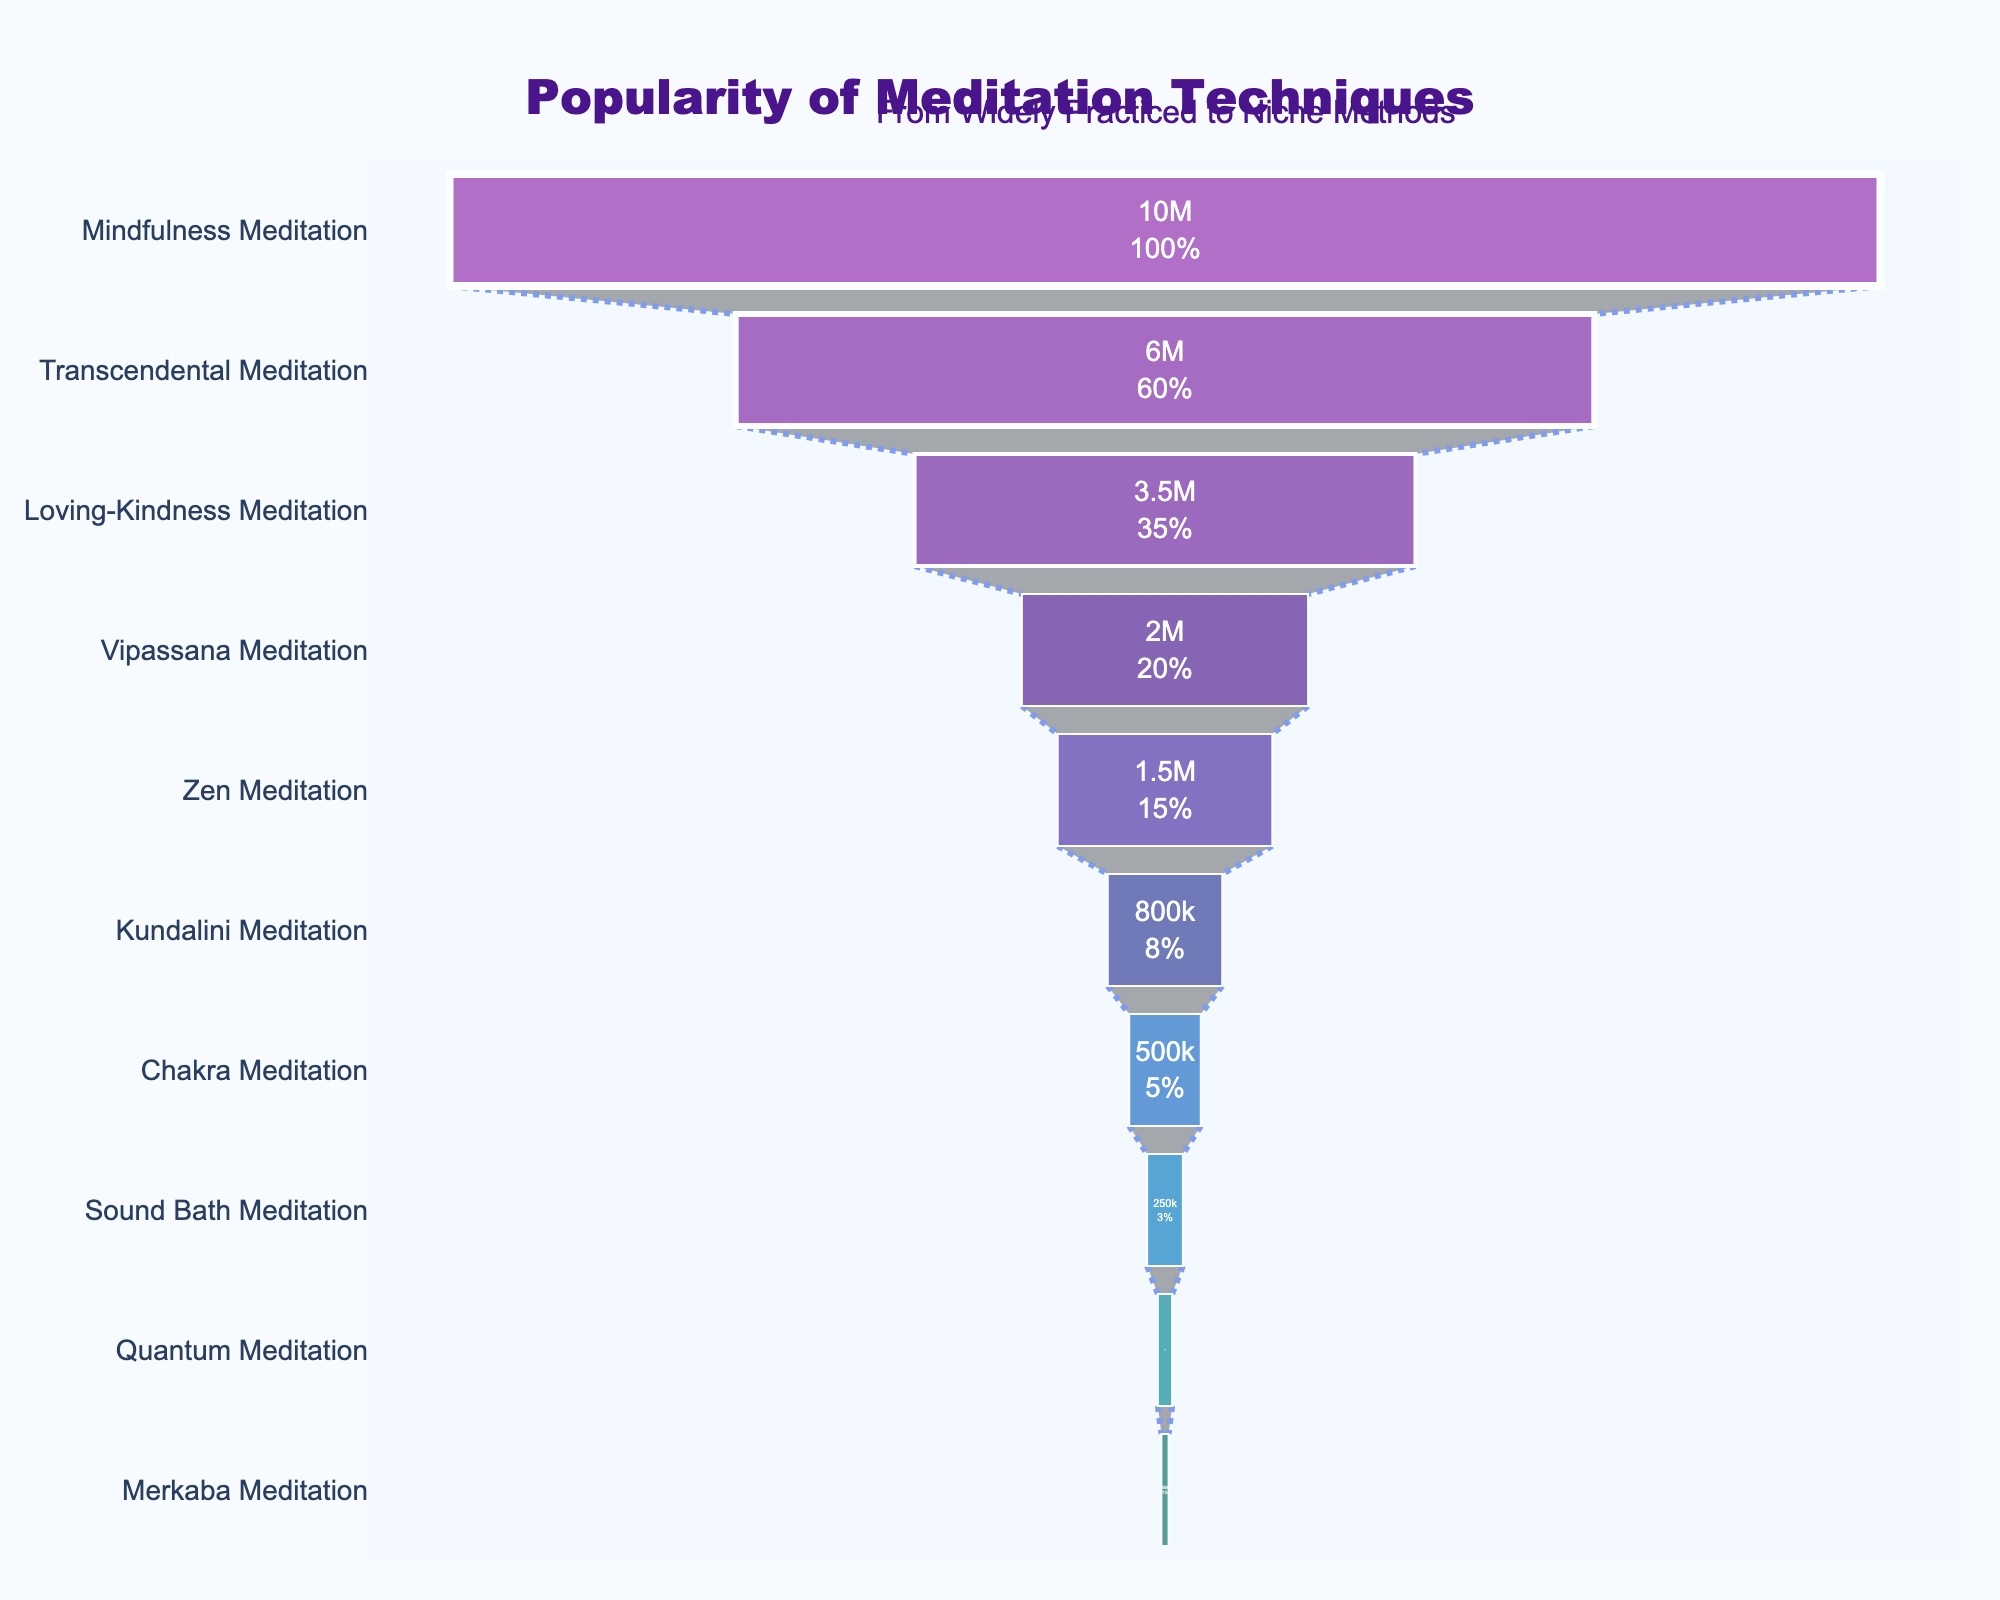What's the title of the chart? The title of the chart is displayed prominently at the top of the figure.
Answer: Popularity of Meditation Techniques How many meditation techniques are represented in the chart? Count the number of stages listed along the y-axis of the funnel chart.
Answer: 10 Which meditation technique is practiced by the most people? Identify the stage at the widest part of the funnel chart, usually at the top.
Answer: Mindfulness Meditation What percentage of practitioners use Transcendental Meditation compared to initial total practitioners? The percentage is displayed as part of the text inside the segments of the funnel chart.
Answer: 60% Which two meditation techniques have the least practitioners? Look at the narrowest parts of the funnel chart, which are typically at the bottom.
Answer: Quantum Meditation and Merkaba Meditation What's the difference in the number of practitioners between Zen Meditation and Kundalini Meditation? Subtract the number of practitioners of Kundalini Meditation from Zen Meditation. Zen Meditation: 1,500,000; Kundalini Meditation: 800,000; 1,500,000 - 800,000 = 700,000
Answer: 700,000 What is the sum of practitioners of the three least popular techniques? Add the number of practitioners for the three stages at the narrowest end of the chart. Quantum Meditation: 100,000; Sound Bath Meditation: 250,000; Merkaba Meditation: 50,000; 100,000 + 250,000 + 50,000 = 400,000
Answer: 400,000 Which meditation technique has half as many practitioners as Mindfulness Meditation? Identify the stage where the number of practitioners is half of Mindfulness Meditation's 10,000,000. 10,000,000 / 2 = 5,000,000. There is no exact half, closest is Transcendental Meditation which is 6,000,000.
Answer: None (Closest is Transcendental Meditation) Are there more practitioners of Zen Meditation or Loving-Kindness Meditation? Compare the number of practitioners for Zen Meditation and Loving-Kindness Meditation. Zen Meditation: 1,500,000; Loving-Kindness Meditation: 3,500,000
Answer: Loving-Kindness Meditation 